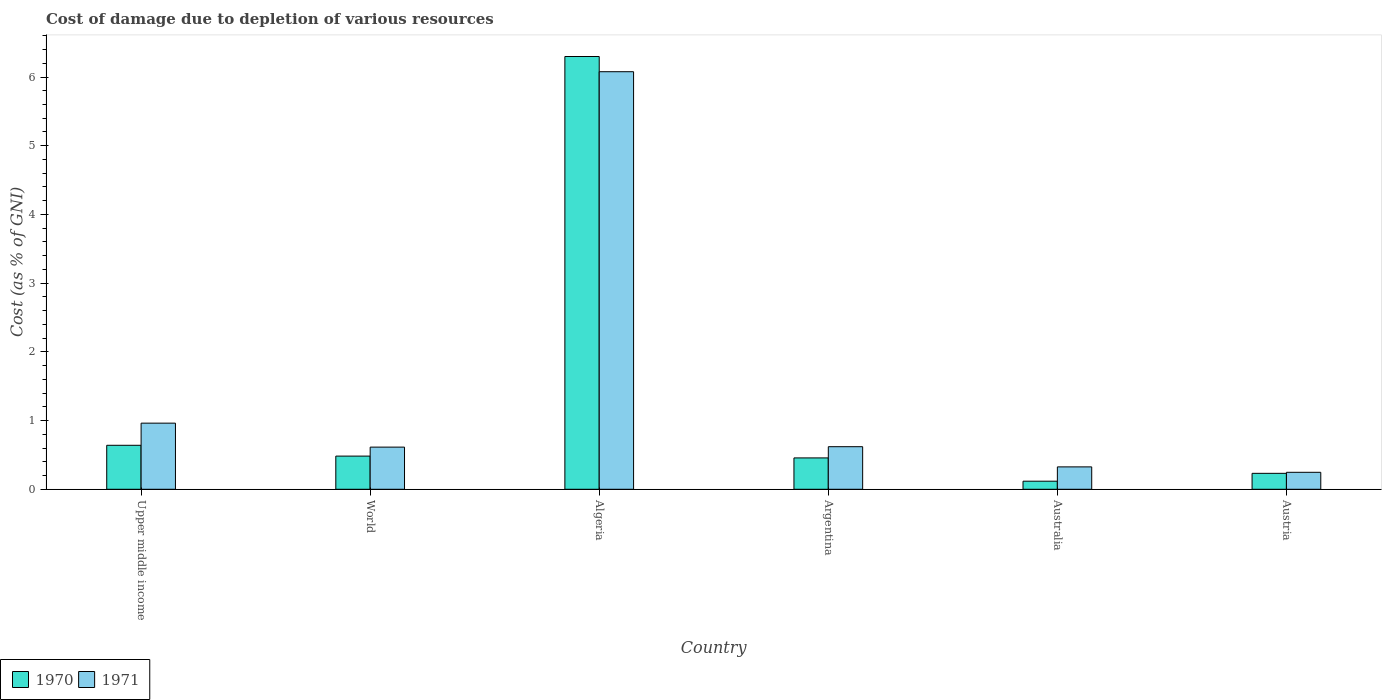Are the number of bars per tick equal to the number of legend labels?
Ensure brevity in your answer.  Yes. Are the number of bars on each tick of the X-axis equal?
Keep it short and to the point. Yes. How many bars are there on the 3rd tick from the left?
Your answer should be compact. 2. How many bars are there on the 5th tick from the right?
Your answer should be compact. 2. What is the label of the 6th group of bars from the left?
Provide a short and direct response. Austria. What is the cost of damage caused due to the depletion of various resources in 1970 in Algeria?
Provide a succinct answer. 6.3. Across all countries, what is the maximum cost of damage caused due to the depletion of various resources in 1971?
Provide a succinct answer. 6.08. Across all countries, what is the minimum cost of damage caused due to the depletion of various resources in 1971?
Give a very brief answer. 0.25. In which country was the cost of damage caused due to the depletion of various resources in 1971 maximum?
Provide a short and direct response. Algeria. In which country was the cost of damage caused due to the depletion of various resources in 1971 minimum?
Your answer should be very brief. Austria. What is the total cost of damage caused due to the depletion of various resources in 1970 in the graph?
Make the answer very short. 8.23. What is the difference between the cost of damage caused due to the depletion of various resources in 1971 in Argentina and that in World?
Your answer should be very brief. 0.01. What is the difference between the cost of damage caused due to the depletion of various resources in 1971 in Australia and the cost of damage caused due to the depletion of various resources in 1970 in Austria?
Your answer should be very brief. 0.09. What is the average cost of damage caused due to the depletion of various resources in 1970 per country?
Offer a terse response. 1.37. What is the difference between the cost of damage caused due to the depletion of various resources of/in 1970 and cost of damage caused due to the depletion of various resources of/in 1971 in Upper middle income?
Make the answer very short. -0.32. In how many countries, is the cost of damage caused due to the depletion of various resources in 1970 greater than 4.8 %?
Provide a short and direct response. 1. What is the ratio of the cost of damage caused due to the depletion of various resources in 1971 in Australia to that in World?
Offer a terse response. 0.53. Is the cost of damage caused due to the depletion of various resources in 1970 in Austria less than that in Upper middle income?
Your answer should be very brief. Yes. What is the difference between the highest and the second highest cost of damage caused due to the depletion of various resources in 1971?
Ensure brevity in your answer.  0.34. What is the difference between the highest and the lowest cost of damage caused due to the depletion of various resources in 1970?
Your answer should be compact. 6.18. In how many countries, is the cost of damage caused due to the depletion of various resources in 1970 greater than the average cost of damage caused due to the depletion of various resources in 1970 taken over all countries?
Offer a very short reply. 1. What does the 1st bar from the left in Australia represents?
Make the answer very short. 1970. How many countries are there in the graph?
Give a very brief answer. 6. What is the difference between two consecutive major ticks on the Y-axis?
Offer a very short reply. 1. Are the values on the major ticks of Y-axis written in scientific E-notation?
Give a very brief answer. No. Does the graph contain any zero values?
Offer a very short reply. No. Where does the legend appear in the graph?
Provide a succinct answer. Bottom left. What is the title of the graph?
Your response must be concise. Cost of damage due to depletion of various resources. What is the label or title of the X-axis?
Make the answer very short. Country. What is the label or title of the Y-axis?
Your answer should be very brief. Cost (as % of GNI). What is the Cost (as % of GNI) of 1970 in Upper middle income?
Your response must be concise. 0.64. What is the Cost (as % of GNI) in 1971 in Upper middle income?
Your answer should be very brief. 0.96. What is the Cost (as % of GNI) of 1970 in World?
Your answer should be very brief. 0.48. What is the Cost (as % of GNI) in 1971 in World?
Offer a terse response. 0.61. What is the Cost (as % of GNI) in 1970 in Algeria?
Your response must be concise. 6.3. What is the Cost (as % of GNI) in 1971 in Algeria?
Your response must be concise. 6.08. What is the Cost (as % of GNI) of 1970 in Argentina?
Offer a terse response. 0.46. What is the Cost (as % of GNI) of 1971 in Argentina?
Offer a very short reply. 0.62. What is the Cost (as % of GNI) of 1970 in Australia?
Your answer should be compact. 0.12. What is the Cost (as % of GNI) of 1971 in Australia?
Your response must be concise. 0.33. What is the Cost (as % of GNI) of 1970 in Austria?
Your response must be concise. 0.23. What is the Cost (as % of GNI) in 1971 in Austria?
Give a very brief answer. 0.25. Across all countries, what is the maximum Cost (as % of GNI) in 1970?
Make the answer very short. 6.3. Across all countries, what is the maximum Cost (as % of GNI) of 1971?
Your response must be concise. 6.08. Across all countries, what is the minimum Cost (as % of GNI) in 1970?
Your response must be concise. 0.12. Across all countries, what is the minimum Cost (as % of GNI) in 1971?
Ensure brevity in your answer.  0.25. What is the total Cost (as % of GNI) of 1970 in the graph?
Offer a very short reply. 8.23. What is the total Cost (as % of GNI) of 1971 in the graph?
Provide a succinct answer. 8.85. What is the difference between the Cost (as % of GNI) of 1970 in Upper middle income and that in World?
Your answer should be very brief. 0.16. What is the difference between the Cost (as % of GNI) of 1971 in Upper middle income and that in World?
Provide a short and direct response. 0.35. What is the difference between the Cost (as % of GNI) of 1970 in Upper middle income and that in Algeria?
Ensure brevity in your answer.  -5.66. What is the difference between the Cost (as % of GNI) in 1971 in Upper middle income and that in Algeria?
Your answer should be compact. -5.11. What is the difference between the Cost (as % of GNI) in 1970 in Upper middle income and that in Argentina?
Give a very brief answer. 0.18. What is the difference between the Cost (as % of GNI) in 1971 in Upper middle income and that in Argentina?
Provide a short and direct response. 0.34. What is the difference between the Cost (as % of GNI) of 1970 in Upper middle income and that in Australia?
Provide a succinct answer. 0.52. What is the difference between the Cost (as % of GNI) of 1971 in Upper middle income and that in Australia?
Ensure brevity in your answer.  0.64. What is the difference between the Cost (as % of GNI) of 1970 in Upper middle income and that in Austria?
Keep it short and to the point. 0.41. What is the difference between the Cost (as % of GNI) of 1971 in Upper middle income and that in Austria?
Give a very brief answer. 0.72. What is the difference between the Cost (as % of GNI) of 1970 in World and that in Algeria?
Provide a succinct answer. -5.82. What is the difference between the Cost (as % of GNI) of 1971 in World and that in Algeria?
Give a very brief answer. -5.46. What is the difference between the Cost (as % of GNI) in 1970 in World and that in Argentina?
Provide a short and direct response. 0.03. What is the difference between the Cost (as % of GNI) in 1971 in World and that in Argentina?
Your answer should be compact. -0.01. What is the difference between the Cost (as % of GNI) in 1970 in World and that in Australia?
Offer a terse response. 0.37. What is the difference between the Cost (as % of GNI) in 1971 in World and that in Australia?
Offer a very short reply. 0.29. What is the difference between the Cost (as % of GNI) of 1970 in World and that in Austria?
Offer a terse response. 0.25. What is the difference between the Cost (as % of GNI) in 1971 in World and that in Austria?
Offer a terse response. 0.37. What is the difference between the Cost (as % of GNI) of 1970 in Algeria and that in Argentina?
Provide a short and direct response. 5.84. What is the difference between the Cost (as % of GNI) in 1971 in Algeria and that in Argentina?
Provide a succinct answer. 5.46. What is the difference between the Cost (as % of GNI) in 1970 in Algeria and that in Australia?
Your response must be concise. 6.18. What is the difference between the Cost (as % of GNI) in 1971 in Algeria and that in Australia?
Ensure brevity in your answer.  5.75. What is the difference between the Cost (as % of GNI) of 1970 in Algeria and that in Austria?
Give a very brief answer. 6.07. What is the difference between the Cost (as % of GNI) in 1971 in Algeria and that in Austria?
Offer a very short reply. 5.83. What is the difference between the Cost (as % of GNI) of 1970 in Argentina and that in Australia?
Your answer should be compact. 0.34. What is the difference between the Cost (as % of GNI) in 1971 in Argentina and that in Australia?
Your answer should be compact. 0.29. What is the difference between the Cost (as % of GNI) of 1970 in Argentina and that in Austria?
Your response must be concise. 0.22. What is the difference between the Cost (as % of GNI) of 1971 in Argentina and that in Austria?
Your response must be concise. 0.37. What is the difference between the Cost (as % of GNI) of 1970 in Australia and that in Austria?
Your response must be concise. -0.11. What is the difference between the Cost (as % of GNI) in 1971 in Australia and that in Austria?
Offer a very short reply. 0.08. What is the difference between the Cost (as % of GNI) of 1970 in Upper middle income and the Cost (as % of GNI) of 1971 in World?
Provide a short and direct response. 0.03. What is the difference between the Cost (as % of GNI) in 1970 in Upper middle income and the Cost (as % of GNI) in 1971 in Algeria?
Ensure brevity in your answer.  -5.44. What is the difference between the Cost (as % of GNI) of 1970 in Upper middle income and the Cost (as % of GNI) of 1971 in Argentina?
Your response must be concise. 0.02. What is the difference between the Cost (as % of GNI) in 1970 in Upper middle income and the Cost (as % of GNI) in 1971 in Australia?
Offer a terse response. 0.31. What is the difference between the Cost (as % of GNI) of 1970 in Upper middle income and the Cost (as % of GNI) of 1971 in Austria?
Your response must be concise. 0.39. What is the difference between the Cost (as % of GNI) of 1970 in World and the Cost (as % of GNI) of 1971 in Algeria?
Ensure brevity in your answer.  -5.59. What is the difference between the Cost (as % of GNI) of 1970 in World and the Cost (as % of GNI) of 1971 in Argentina?
Provide a short and direct response. -0.14. What is the difference between the Cost (as % of GNI) in 1970 in World and the Cost (as % of GNI) in 1971 in Australia?
Offer a very short reply. 0.16. What is the difference between the Cost (as % of GNI) of 1970 in World and the Cost (as % of GNI) of 1971 in Austria?
Ensure brevity in your answer.  0.24. What is the difference between the Cost (as % of GNI) in 1970 in Algeria and the Cost (as % of GNI) in 1971 in Argentina?
Your answer should be compact. 5.68. What is the difference between the Cost (as % of GNI) in 1970 in Algeria and the Cost (as % of GNI) in 1971 in Australia?
Your answer should be very brief. 5.97. What is the difference between the Cost (as % of GNI) of 1970 in Algeria and the Cost (as % of GNI) of 1971 in Austria?
Provide a succinct answer. 6.05. What is the difference between the Cost (as % of GNI) in 1970 in Argentina and the Cost (as % of GNI) in 1971 in Australia?
Give a very brief answer. 0.13. What is the difference between the Cost (as % of GNI) in 1970 in Argentina and the Cost (as % of GNI) in 1971 in Austria?
Provide a succinct answer. 0.21. What is the difference between the Cost (as % of GNI) of 1970 in Australia and the Cost (as % of GNI) of 1971 in Austria?
Ensure brevity in your answer.  -0.13. What is the average Cost (as % of GNI) in 1970 per country?
Offer a very short reply. 1.37. What is the average Cost (as % of GNI) of 1971 per country?
Your answer should be compact. 1.47. What is the difference between the Cost (as % of GNI) of 1970 and Cost (as % of GNI) of 1971 in Upper middle income?
Give a very brief answer. -0.32. What is the difference between the Cost (as % of GNI) in 1970 and Cost (as % of GNI) in 1971 in World?
Keep it short and to the point. -0.13. What is the difference between the Cost (as % of GNI) of 1970 and Cost (as % of GNI) of 1971 in Algeria?
Offer a very short reply. 0.22. What is the difference between the Cost (as % of GNI) in 1970 and Cost (as % of GNI) in 1971 in Argentina?
Offer a terse response. -0.16. What is the difference between the Cost (as % of GNI) of 1970 and Cost (as % of GNI) of 1971 in Australia?
Ensure brevity in your answer.  -0.21. What is the difference between the Cost (as % of GNI) in 1970 and Cost (as % of GNI) in 1971 in Austria?
Offer a very short reply. -0.01. What is the ratio of the Cost (as % of GNI) in 1970 in Upper middle income to that in World?
Provide a succinct answer. 1.33. What is the ratio of the Cost (as % of GNI) of 1971 in Upper middle income to that in World?
Provide a succinct answer. 1.57. What is the ratio of the Cost (as % of GNI) of 1970 in Upper middle income to that in Algeria?
Ensure brevity in your answer.  0.1. What is the ratio of the Cost (as % of GNI) of 1971 in Upper middle income to that in Algeria?
Give a very brief answer. 0.16. What is the ratio of the Cost (as % of GNI) in 1970 in Upper middle income to that in Argentina?
Keep it short and to the point. 1.4. What is the ratio of the Cost (as % of GNI) in 1971 in Upper middle income to that in Argentina?
Offer a terse response. 1.55. What is the ratio of the Cost (as % of GNI) of 1970 in Upper middle income to that in Australia?
Your response must be concise. 5.45. What is the ratio of the Cost (as % of GNI) in 1971 in Upper middle income to that in Australia?
Ensure brevity in your answer.  2.95. What is the ratio of the Cost (as % of GNI) in 1970 in Upper middle income to that in Austria?
Keep it short and to the point. 2.76. What is the ratio of the Cost (as % of GNI) of 1971 in Upper middle income to that in Austria?
Make the answer very short. 3.9. What is the ratio of the Cost (as % of GNI) in 1970 in World to that in Algeria?
Ensure brevity in your answer.  0.08. What is the ratio of the Cost (as % of GNI) in 1971 in World to that in Algeria?
Your answer should be very brief. 0.1. What is the ratio of the Cost (as % of GNI) in 1970 in World to that in Argentina?
Your answer should be compact. 1.06. What is the ratio of the Cost (as % of GNI) of 1970 in World to that in Australia?
Offer a very short reply. 4.11. What is the ratio of the Cost (as % of GNI) of 1971 in World to that in Australia?
Provide a succinct answer. 1.88. What is the ratio of the Cost (as % of GNI) of 1970 in World to that in Austria?
Make the answer very short. 2.08. What is the ratio of the Cost (as % of GNI) in 1971 in World to that in Austria?
Offer a terse response. 2.48. What is the ratio of the Cost (as % of GNI) in 1970 in Algeria to that in Argentina?
Your response must be concise. 13.8. What is the ratio of the Cost (as % of GNI) in 1971 in Algeria to that in Argentina?
Offer a terse response. 9.81. What is the ratio of the Cost (as % of GNI) in 1970 in Algeria to that in Australia?
Provide a succinct answer. 53.61. What is the ratio of the Cost (as % of GNI) in 1971 in Algeria to that in Australia?
Give a very brief answer. 18.65. What is the ratio of the Cost (as % of GNI) in 1970 in Algeria to that in Austria?
Keep it short and to the point. 27.15. What is the ratio of the Cost (as % of GNI) in 1971 in Algeria to that in Austria?
Give a very brief answer. 24.61. What is the ratio of the Cost (as % of GNI) in 1970 in Argentina to that in Australia?
Make the answer very short. 3.89. What is the ratio of the Cost (as % of GNI) of 1971 in Argentina to that in Australia?
Offer a very short reply. 1.9. What is the ratio of the Cost (as % of GNI) in 1970 in Argentina to that in Austria?
Your response must be concise. 1.97. What is the ratio of the Cost (as % of GNI) in 1971 in Argentina to that in Austria?
Provide a short and direct response. 2.51. What is the ratio of the Cost (as % of GNI) of 1970 in Australia to that in Austria?
Keep it short and to the point. 0.51. What is the ratio of the Cost (as % of GNI) of 1971 in Australia to that in Austria?
Provide a short and direct response. 1.32. What is the difference between the highest and the second highest Cost (as % of GNI) in 1970?
Your answer should be very brief. 5.66. What is the difference between the highest and the second highest Cost (as % of GNI) of 1971?
Ensure brevity in your answer.  5.11. What is the difference between the highest and the lowest Cost (as % of GNI) in 1970?
Keep it short and to the point. 6.18. What is the difference between the highest and the lowest Cost (as % of GNI) of 1971?
Offer a very short reply. 5.83. 